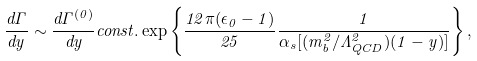Convert formula to latex. <formula><loc_0><loc_0><loc_500><loc_500>\frac { d \Gamma } { d y } \sim \frac { d \Gamma ^ { ( 0 ) } } { d y } c o n s t . \exp \left \{ \frac { 1 2 \pi ( \epsilon _ { 0 } - 1 ) } { 2 5 } \frac { 1 } { \alpha _ { s } [ ( m _ { b } ^ { 2 } / \Lambda _ { Q C D } ^ { 2 } ) ( 1 - y ) ] } \right \} ,</formula> 